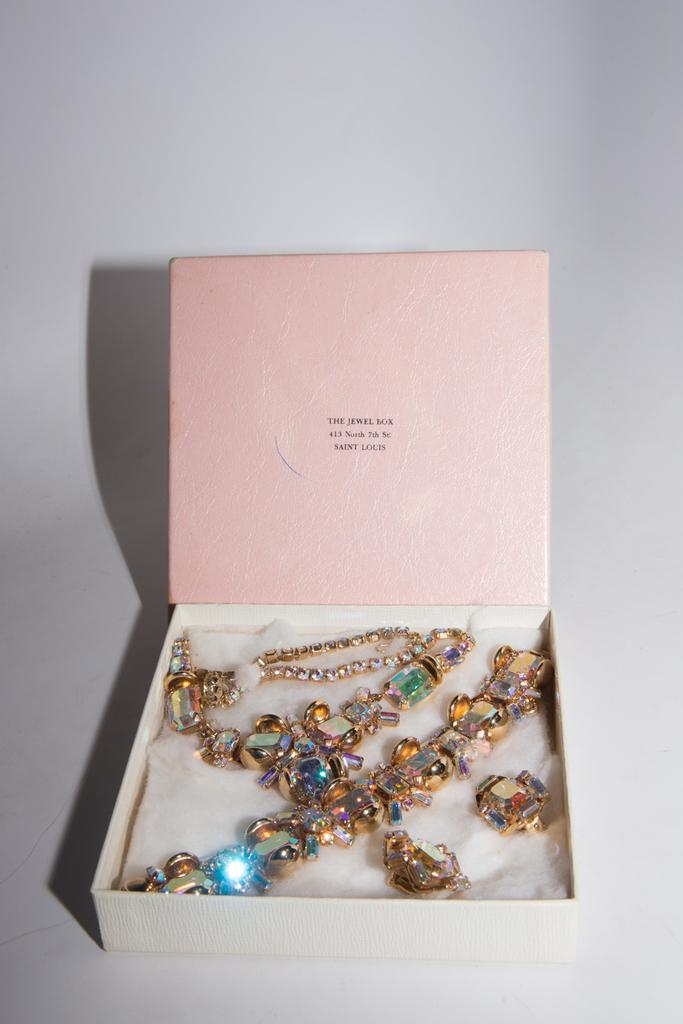What is the main object in the middle of the image? There is a box in the middle of the image. What is inside the box? The box contains ornaments. What type of oatmeal is being prepared in the image? There is no oatmeal present in the image; it features a box containing ornaments. What unit of measurement is used to determine the size of the ornaments in the image? The image does not provide information about the size or units of measurement for the ornaments. 